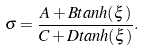<formula> <loc_0><loc_0><loc_500><loc_500>\sigma = \frac { A + B t a n h ( \xi ) } { C + D t a n h ( \xi ) } .</formula> 